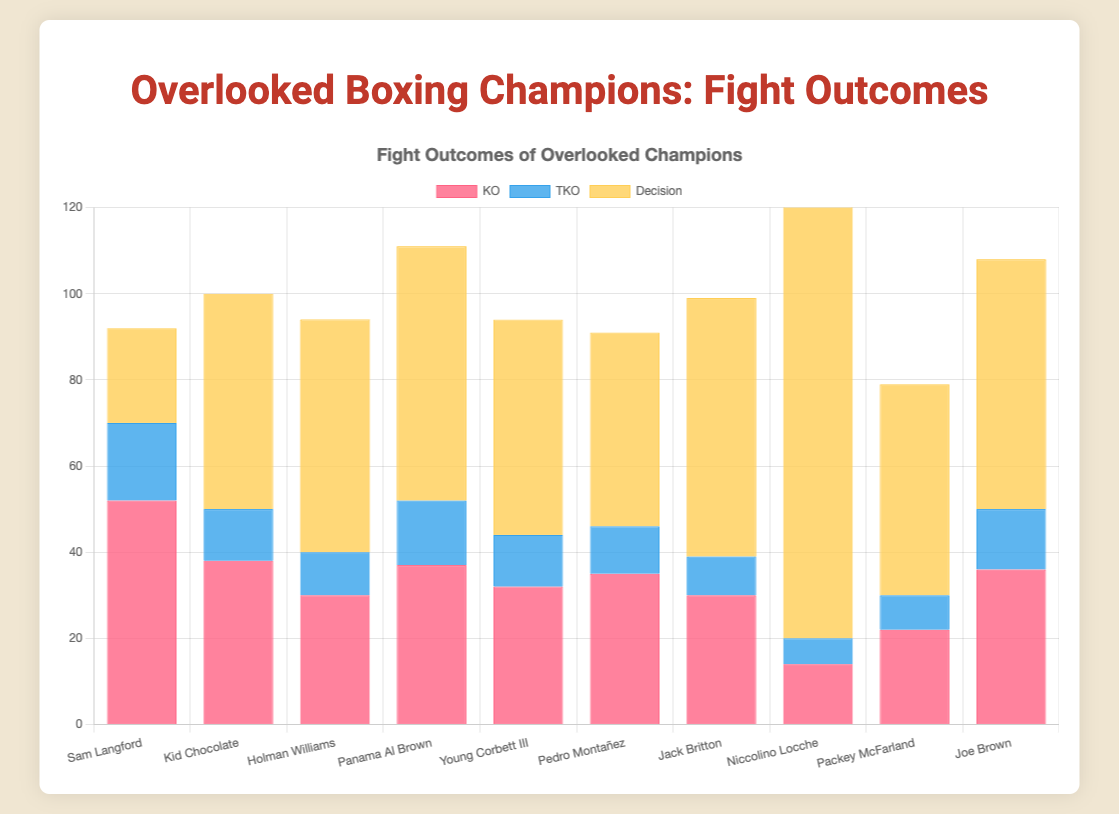Which fighter has the highest number of Decision wins? The Decision wins are represented by the yellow bars in the chart. By comparing their heights, the highest bar belongs to Niccolino Locche.
Answer: Niccolino Locche Between Holman Williams and Kid Chocolate, who has more TKO wins? TKO wins are represented by the blue bars. By comparing the blue bars for Holman Williams and Kid Chocolate, Kid Chocolate has more with 12 compared to Holman Williams' 10.
Answer: Kid Chocolate What is the sum of KO wins for all the American fighters? Summing up the KO wins for the American fighters: Holman Williams (30) + Young Corbett III (32) + Jack Britton (30) + Packey McFarland (22) + Joe Brown (36) = 150.
Answer: 150 Which nationality has the highest total number of Decision wins, and what's the sum? By summing the Decision wins of American fighters: Holman Williams (54) + Young Corbett III (50) + Jack Britton (60) + Packey McFarland (49) + Joe Brown (58) = 271. The highest total belongs to the Americans.
Answer: American, 271 Who has more combined TKO and Decision wins, Pedro Montañez or Sam Langford? Adding the TKO and Decision wins: Pedro Montañez: TKO (11) + Decision (45) = 56. Sam Langford: TKO (18) + Decision (22) = 40. Pedro Montañez has more combined wins.
Answer: Pedro Montañez Which fight outcome is least common for Niccolino Locche? For Niccolino Locche, comparing KO (14), TKO (6), and Decision (111), TKO is the least common.
Answer: TKO Which fighter has the closest number of KO and Decision wins, based on the bar heights? By comparing the KO and Decision wins for each fighter, Sam Langford has 52 KOs and 22 Decisions, which is relatively close in proportion compared to others.
Answer: Sam Langford How many more Decision wins does Panama Al Brown have compared to Holman Williams? Panama Al Brown has 59 Decision wins, while Holman Williams has 54. The difference is 59 - 54 = 5.
Answer: 5 Which fighter has the lowest combined KO and TKO wins, and what is the sum? Summing KO and TKO wins for each fighter, Niccolino Locche has KO (14) + TKO (6) = 20, which is the lowest.
Answer: Niccolino Locche, 20 In terms of KO wins, who is the closest in number to Pedro Montañez? Pedro Montañez has 35 KO wins. Joe Brown is the closest with 36 KO wins.
Answer: Joe Brown 